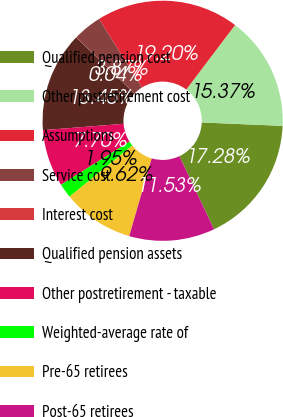Convert chart to OTSL. <chart><loc_0><loc_0><loc_500><loc_500><pie_chart><fcel>Qualified pension cost<fcel>Other postretirement cost<fcel>Assumptions<fcel>Service cost<fcel>Interest cost<fcel>Qualified pension assets<fcel>Other postretirement - taxable<fcel>Weighted-average rate of<fcel>Pre-65 retirees<fcel>Post-65 retirees<nl><fcel>17.28%<fcel>15.37%<fcel>19.2%<fcel>3.87%<fcel>0.04%<fcel>13.45%<fcel>7.7%<fcel>1.95%<fcel>9.62%<fcel>11.53%<nl></chart> 